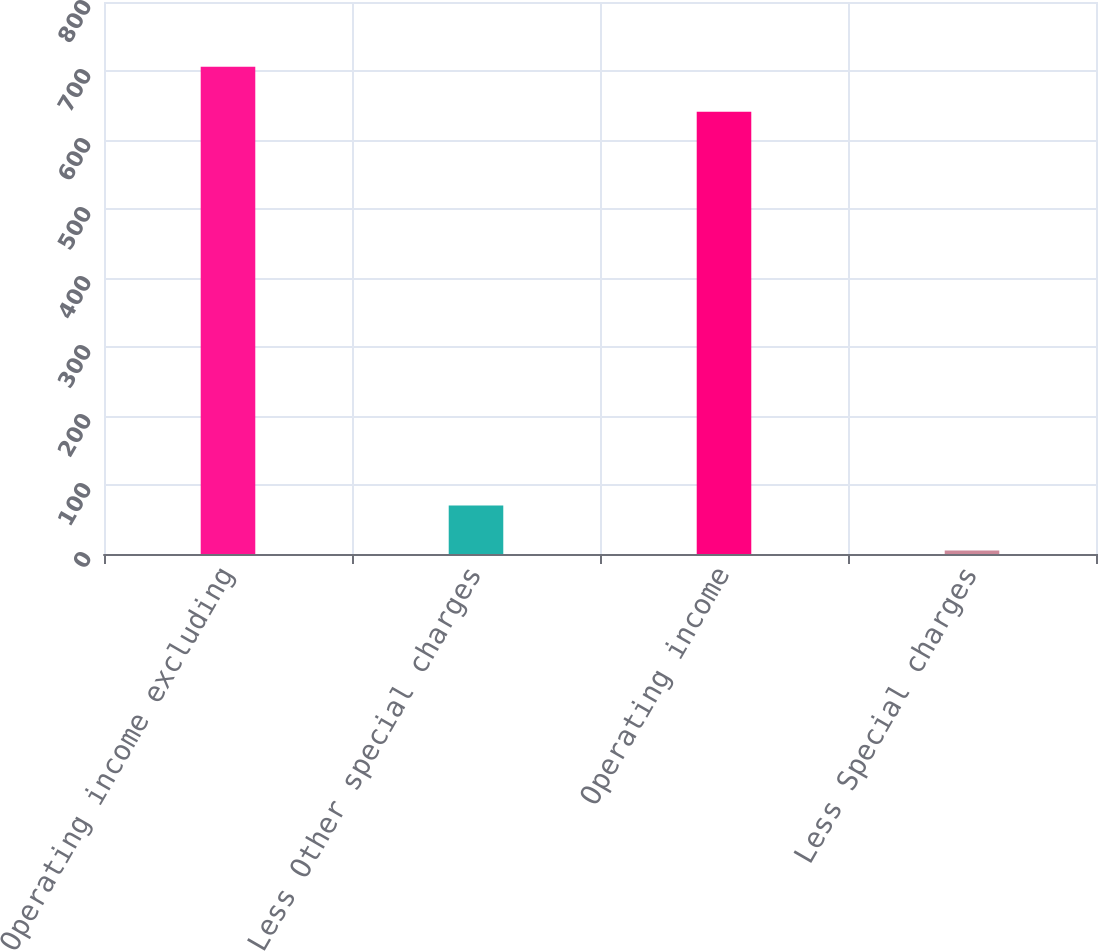<chart> <loc_0><loc_0><loc_500><loc_500><bar_chart><fcel>Operating income excluding<fcel>Less Other special charges<fcel>Operating income<fcel>Less Special charges<nl><fcel>706.18<fcel>70.38<fcel>641<fcel>5.2<nl></chart> 